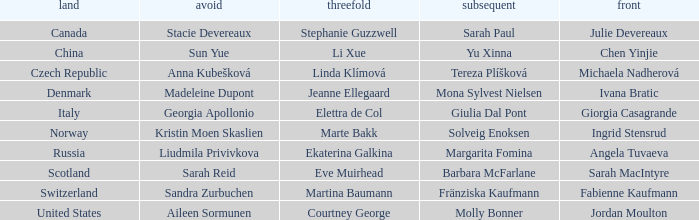What skip has martina baumann as the third? Sandra Zurbuchen. 